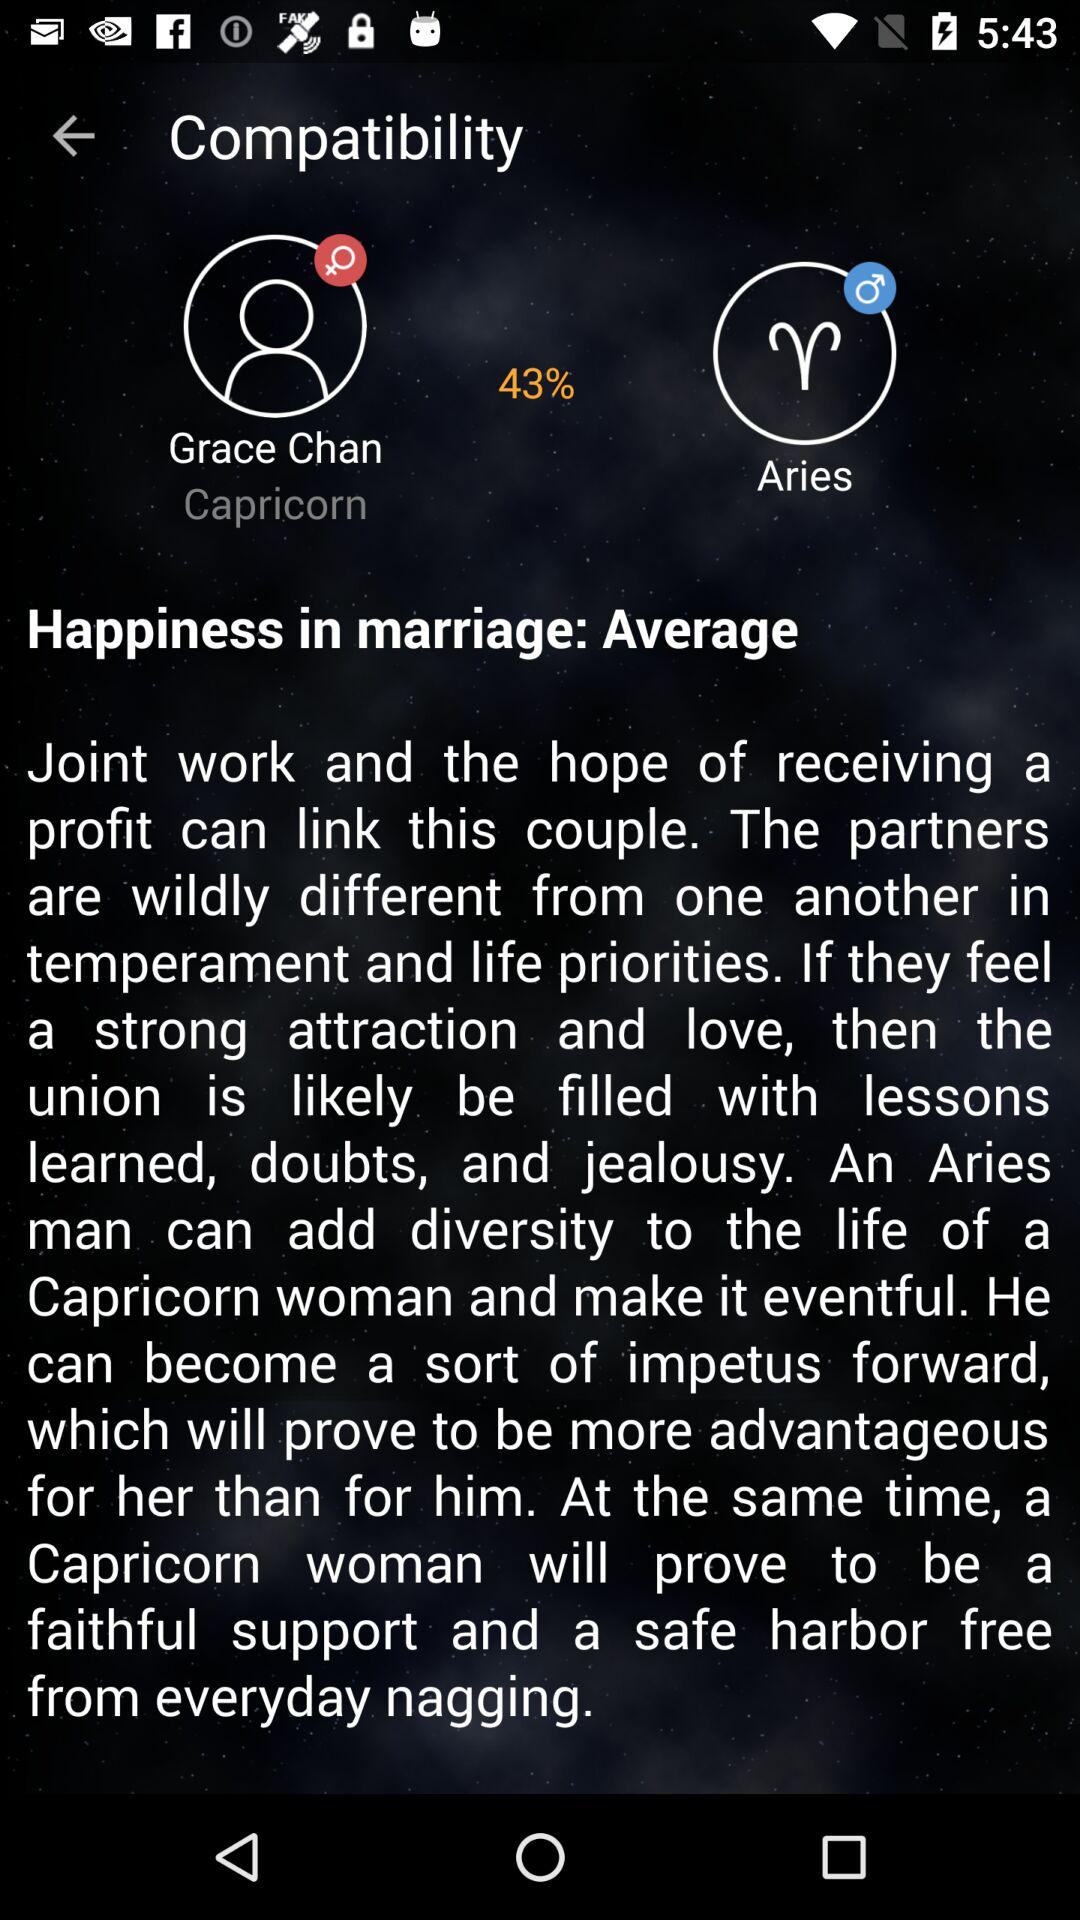What is the compatibility percentage between Capricorn and Aries? The compatibility percentage is 43. 